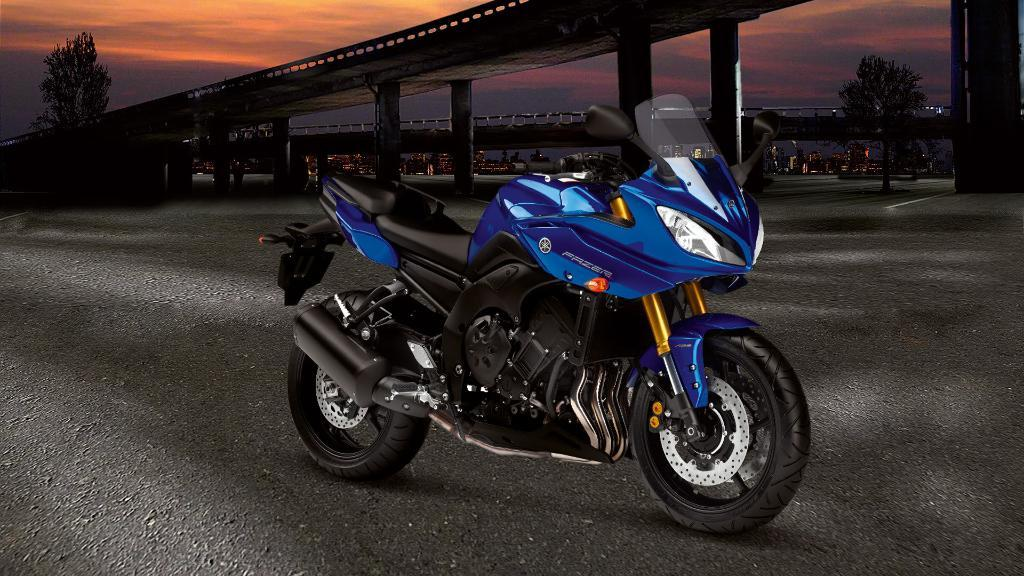What is the main object in the image? There is a bike in the image. What can be seen in the background of the image? There are trees, bridges, and buildings in the background of the image. How would you describe the sky in the image? The sky is cloudy in the image. How many beds can be seen in the image? There are no beds present in the image. Is there a squirrel sitting on the bike in the image? There is no squirrel present in the image. 